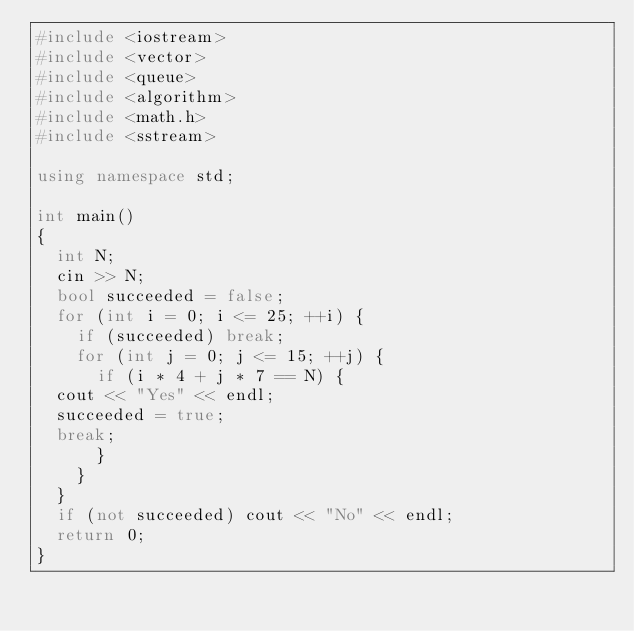<code> <loc_0><loc_0><loc_500><loc_500><_C++_>#include <iostream>
#include <vector>
#include <queue>
#include <algorithm>
#include <math.h>
#include <sstream>

using namespace std;

int main()
{
  int N;
  cin >> N;
  bool succeeded = false;
  for (int i = 0; i <= 25; ++i) {
    if (succeeded) break;
    for (int j = 0; j <= 15; ++j) {
      if (i * 4 + j * 7 == N) {
	cout << "Yes" << endl;
	succeeded = true;
	break;
      }
    }
  }
  if (not succeeded) cout << "No" << endl;
  return 0;
}
</code> 